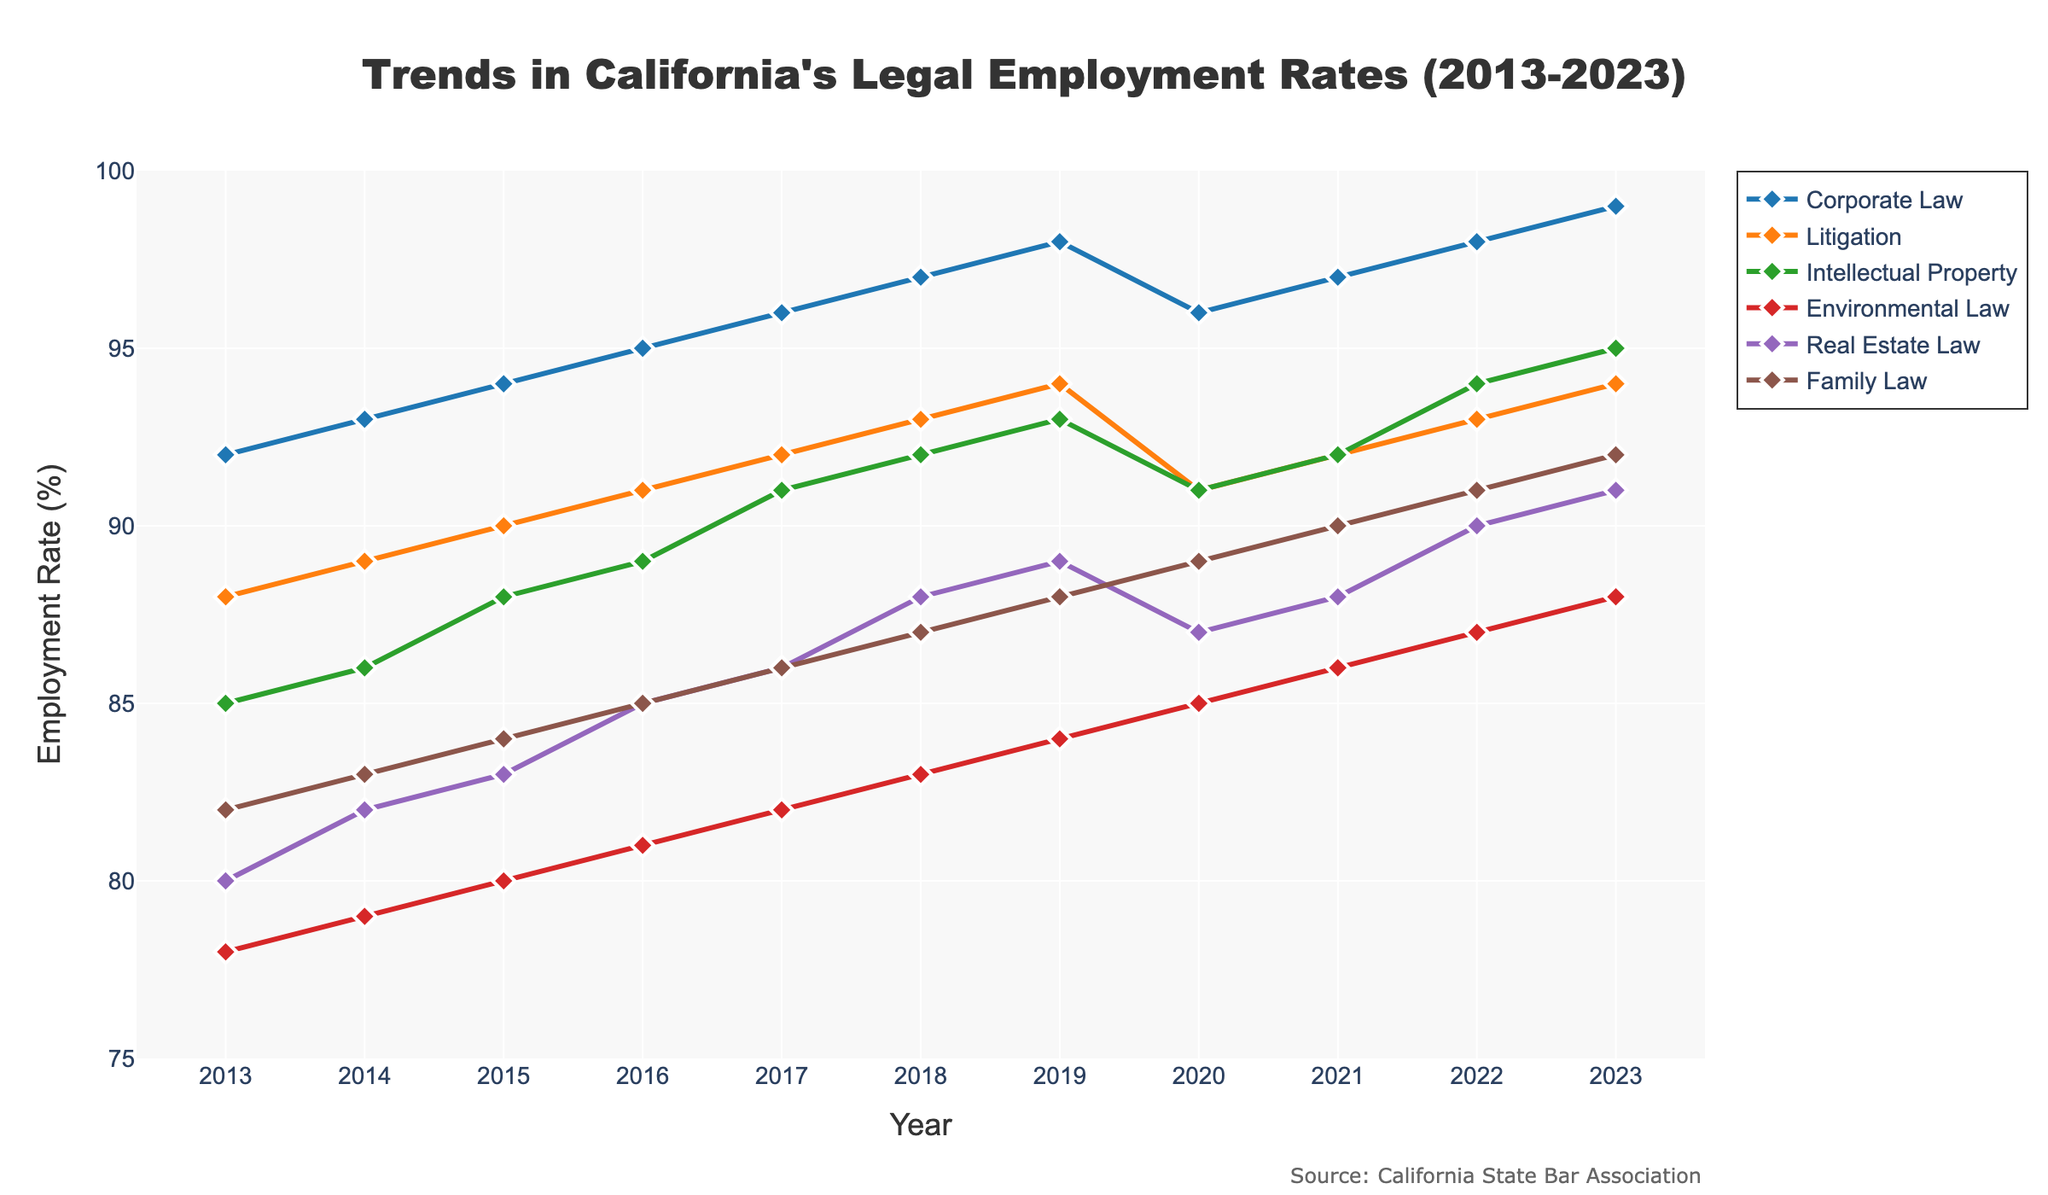What is the trend of employment rates in Corporate Law from 2013 to 2023? The employment rates in Corporate Law have shown a consistent increase from 92% in 2013 to 99% in 2023. This indicates steady growth in employment for Corporate Law over the past decade.
Answer: Consistent increase How do the employment rates of Litigation in 2020 compare to 2022? The employment rate in Litigation in 2020 was 91%, while in 2022 it was 93%. Comparing these two years, the employment rate in Litigation increased by 2%.
Answer: Increased by 2% Which practice area had the least variation in employment rates over the decade? By observing the lines, Family Law shows the smallest incremental changes and the least variation from 82% to 92%. This is compared to other practice areas which have either larger ranges or more fluctuations.
Answer: Family Law What was the difference in employment rate between Intellectual Property and Environmental Law in 2019? In 2019, the employment rate for Intellectual Property was 93%, and for Environmental Law, it was 84%. The difference between them is 93% - 84% = 9%.
Answer: 9% Which year exhibited the highest employment rate in Real Estate Law and what was the rate? The highest employment rate in Real Estate Law was observed in 2023, at 91%. This is the peak over the trend shown in the graph.
Answer: 2023, 91% What can be inferred about the employment trend for Environmental Law from 2013 to 2023? The employment rate in Environmental Law consistently increased every year from 78% in 2013 to 88% in 2023, demonstrating steady growth.
Answer: Steady increase Compare the employment rate trends of Family Law and Corporate Law from 2016 to 2023. Between 2016 and 2023, Corporate Law's employment rate showed a consistent upward trend from 95% to 99%, while Family Law also increased steadily from 85% to 92%. Both practice areas exhibit a positive growth trend, though Corporate Law's rate is generally higher.
Answer: Both increased, Corporate Law higher Which practice area had the highest rise in employment rates from 2016 to 2023, and by how much? To find the practice area with the highest rise, observe the changes: Corporate Law increased from 95% to 99% (+4), Litigation from 91% to 94% (+3), Intellectual Property from 89% to 95% (+6), Environmental Law from 81% to 88% (+7), Real Estate Law from 85% to 91% (+6), and Family Law from 85% to 92% (+7). Environmental Law and Family Law both had the highest rise with an increase of 7%.
Answer: Environmental Law and Family Law, +7% What is the average employment rate for Litigation over the decade? Summing the yearly percentages for Litigation from 2013 to 2023: (88 + 89 + 90 + 91 + 92 + 93 + 94 + 91 + 92 + 93 + 94) = 997. The average over 11 years is 997/11 ≈ 90.7.
Answer: 90.7% 